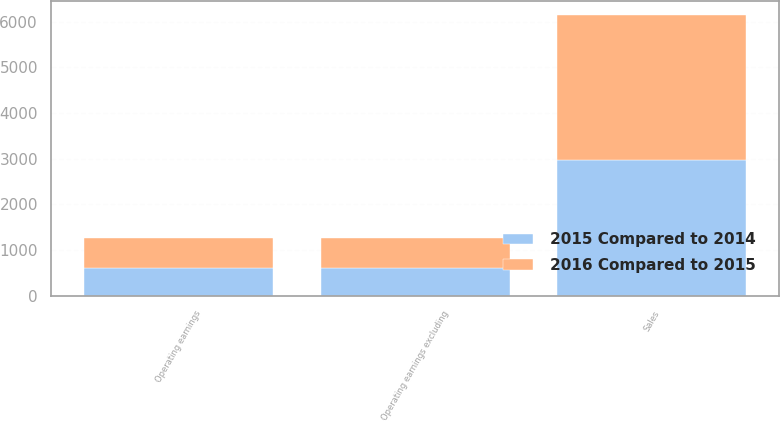Convert chart. <chart><loc_0><loc_0><loc_500><loc_500><stacked_bar_chart><ecel><fcel>Sales<fcel>Operating earnings<fcel>Operating earnings excluding<nl><fcel>2015 Compared to 2014<fcel>2979<fcel>601<fcel>611<nl><fcel>2016 Compared to 2015<fcel>3159<fcel>660<fcel>660<nl></chart> 